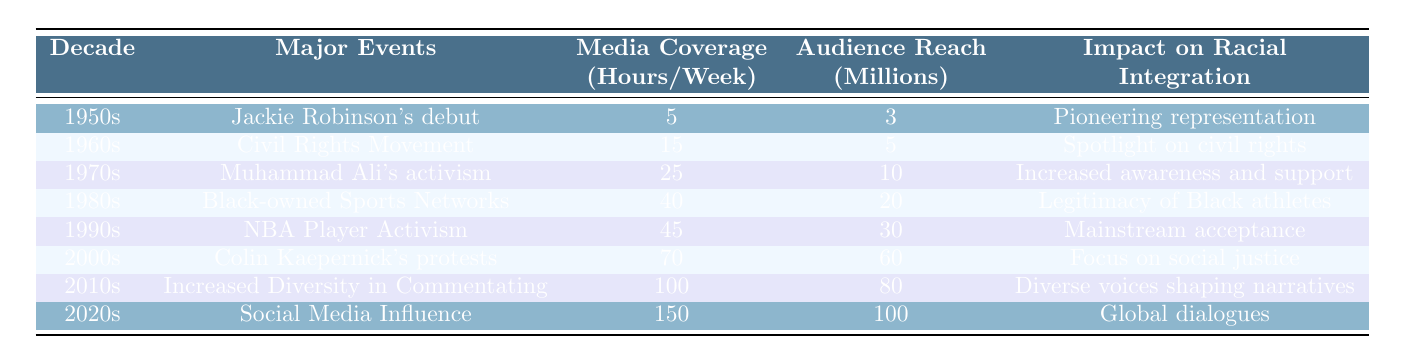What major event is associated with the 1980s in the table? The 1980s major event listed in the table is "Black-owned Sports Networks."
Answer: Black-owned Sports Networks What was the media coverage in the 1960s? According to the table, the media coverage in the 1960s was 15 hours per week.
Answer: 15 hours What decade had the highest audience reach? The 2020s had the highest audience reach at 100 million, according to the table.
Answer: 100 million How many hours of media coverage were reported in the 1970s compared to the 1990s? In the 1970s, there were 25 hours of media coverage, while in the 1990s, there were 45 hours. The difference is 45 - 25 = 20 hours more in the 1990s.
Answer: 20 hours more Which decade is associated with Colin Kaepernick's protests? The decade associated with Colin Kaepernick's protests, as noted in the table, is the 2000s.
Answer: 2000s True or false: The media coverage increased every decade from the 1950s to the 2020s. True, as the data shows that media coverage numbers increased from 5 hours in the 1950s to 150 hours in the 2020s without any declines.
Answer: True What was the average media coverage from the 1980s to the 2020s? First, we add the media coverage hours: 40 (1980s) + 45 (1990s) + 70 (2000s) + 100 (2010s) + 150 (2020s) = 405 hours. There are 5 data points, so we divide: 405 / 5 = 81.
Answer: 81 hours Which decade saw a significant increase in media coverage compared to the 1970s? The 1980s saw media coverage increase to 40 hours, which is a rise from 25 hours in the 1970s, indicating a significant increase.
Answer: 1980s How does the impact on racial integration change from the 1950s to the 2020s? The impact evolves from basic representation in the 1950s to global dialogues in the 2020s, reflecting a journey from pioneering representation to a broader societal conversation on racial issues.
Answer: Evolved from representation to global dialogues What was the audience reach in the 2000s, and how does it compare to the 1950s? In the 2000s, the audience reach was 60 million, compared to 3 million in the 1950s. The increase is 60 - 3 = 57 million.
Answer: 57 million increase 